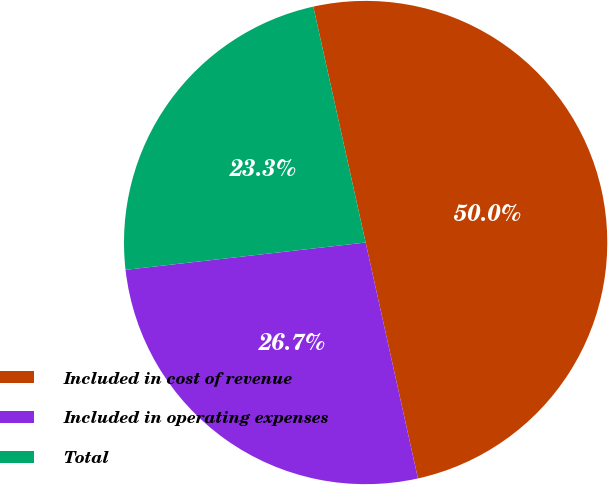Convert chart. <chart><loc_0><loc_0><loc_500><loc_500><pie_chart><fcel>Included in cost of revenue<fcel>Included in operating expenses<fcel>Total<nl><fcel>50.0%<fcel>26.67%<fcel>23.33%<nl></chart> 